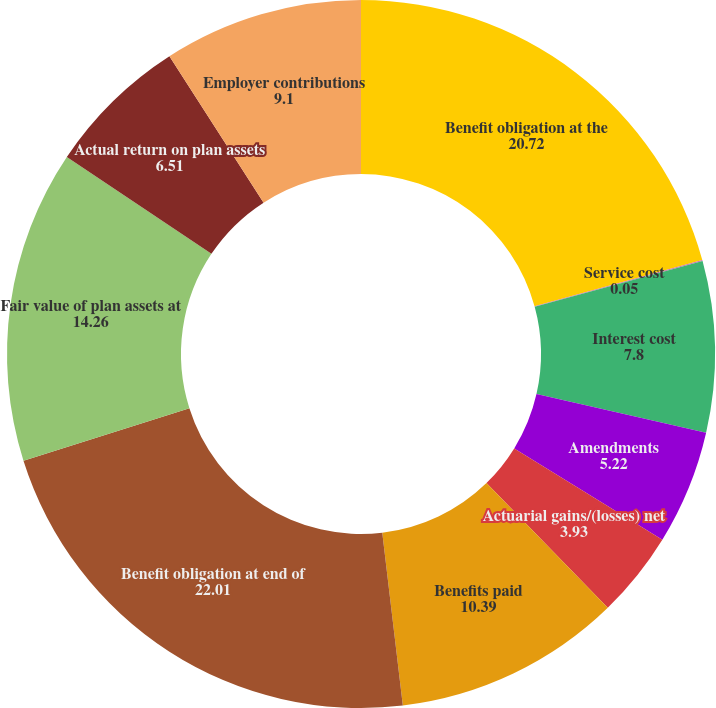Convert chart. <chart><loc_0><loc_0><loc_500><loc_500><pie_chart><fcel>Benefit obligation at the<fcel>Service cost<fcel>Interest cost<fcel>Amendments<fcel>Actuarial gains/(losses) net<fcel>Benefits paid<fcel>Benefit obligation at end of<fcel>Fair value of plan assets at<fcel>Actual return on plan assets<fcel>Employer contributions<nl><fcel>20.72%<fcel>0.05%<fcel>7.8%<fcel>5.22%<fcel>3.93%<fcel>10.39%<fcel>22.01%<fcel>14.26%<fcel>6.51%<fcel>9.1%<nl></chart> 